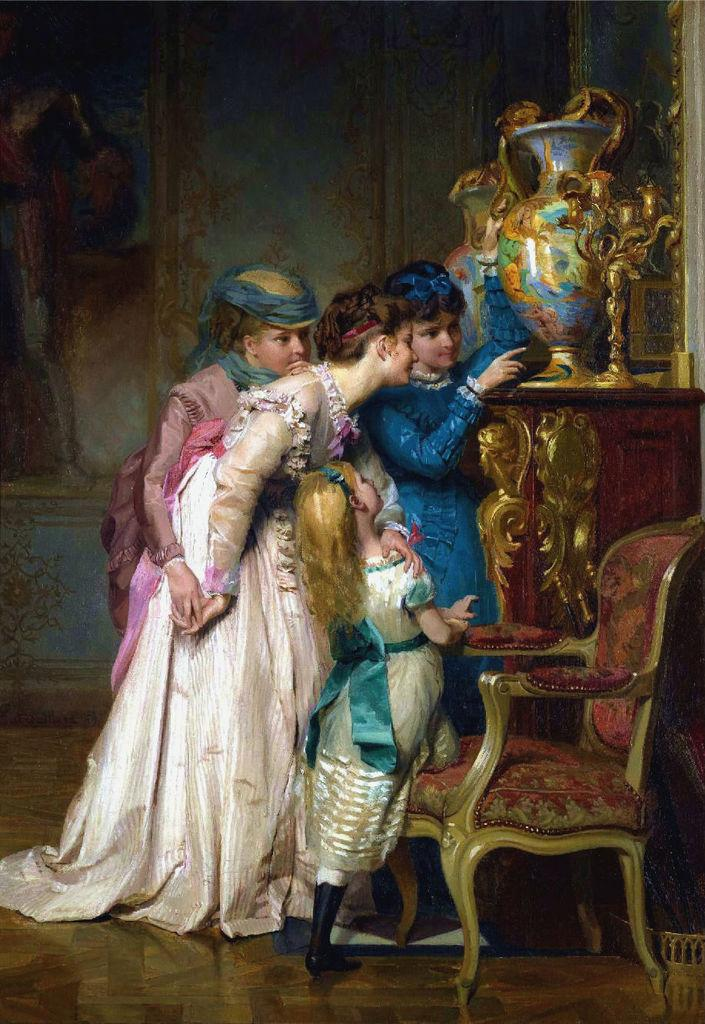How many people are in the foreground of the image? There are four persons standing in the foreground of the image. What are the positions of the three persons in relation to the floor? One person is standing on the floor, another on a chair, and the third on a table. What can be seen on the table in the image? There is a flower vase on the table. What is visible in the background of the image? There is a wall visible in the background of the image. Where was the image taken? The image was taken in a hall. What type of pest can be seen crawling on the wall in the image? There are no pests visible in the image; only the four persons, the flower vase, and the wall are present. Are there any slaves depicted in the image? There is no depiction of slavery or slaves in the image. 